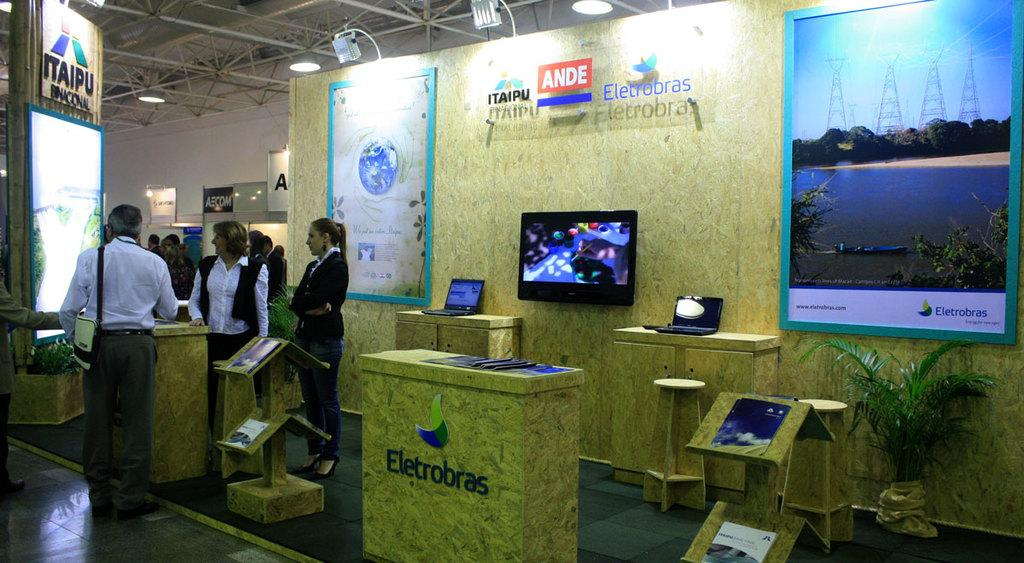<image>
Share a concise interpretation of the image provided. A kiosk with an Ande sign in white on a red background 